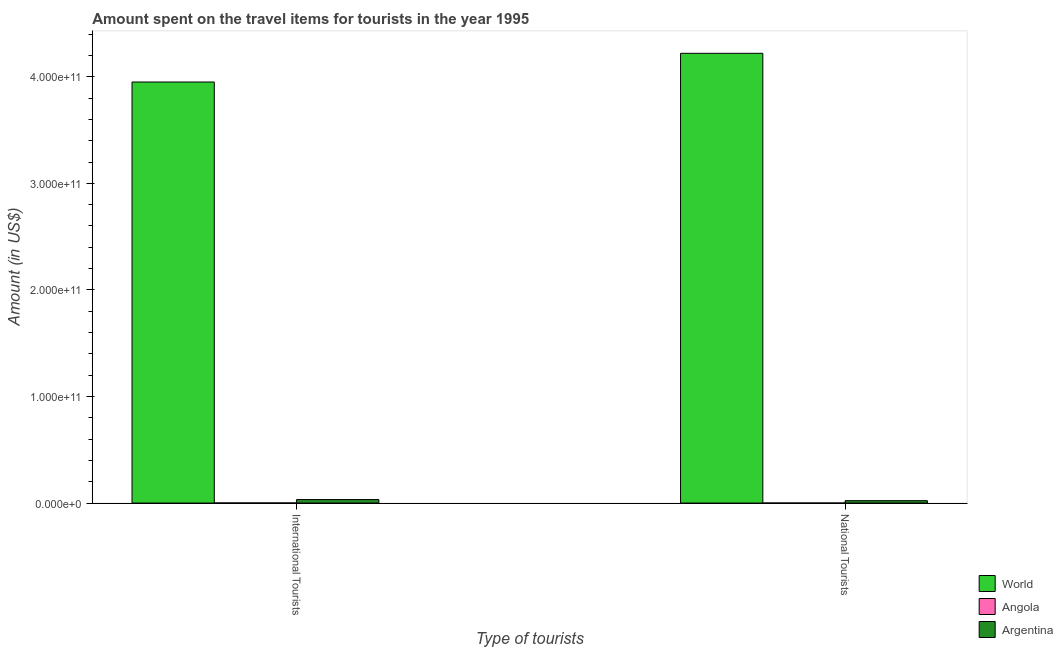How many different coloured bars are there?
Keep it short and to the point. 3. How many groups of bars are there?
Offer a very short reply. 2. What is the label of the 2nd group of bars from the left?
Your answer should be compact. National Tourists. What is the amount spent on travel items of national tourists in World?
Offer a terse response. 4.22e+11. Across all countries, what is the maximum amount spent on travel items of international tourists?
Keep it short and to the point. 3.95e+11. Across all countries, what is the minimum amount spent on travel items of international tourists?
Provide a short and direct response. 7.50e+07. In which country was the amount spent on travel items of international tourists minimum?
Offer a terse response. Angola. What is the total amount spent on travel items of national tourists in the graph?
Your response must be concise. 4.24e+11. What is the difference between the amount spent on travel items of international tourists in Argentina and that in World?
Offer a terse response. -3.92e+11. What is the difference between the amount spent on travel items of national tourists in World and the amount spent on travel items of international tourists in Argentina?
Your answer should be very brief. 4.19e+11. What is the average amount spent on travel items of national tourists per country?
Your answer should be very brief. 1.41e+11. What is the difference between the amount spent on travel items of national tourists and amount spent on travel items of international tourists in Angola?
Offer a very short reply. -6.50e+07. In how many countries, is the amount spent on travel items of national tourists greater than 100000000000 US$?
Give a very brief answer. 1. What is the ratio of the amount spent on travel items of national tourists in Argentina to that in World?
Provide a succinct answer. 0.01. Is the amount spent on travel items of international tourists in Angola less than that in Argentina?
Give a very brief answer. Yes. What does the 3rd bar from the left in National Tourists represents?
Offer a terse response. Argentina. What does the 3rd bar from the right in National Tourists represents?
Offer a very short reply. World. Are all the bars in the graph horizontal?
Your answer should be compact. No. What is the difference between two consecutive major ticks on the Y-axis?
Keep it short and to the point. 1.00e+11. Does the graph contain any zero values?
Give a very brief answer. No. Does the graph contain grids?
Keep it short and to the point. No. What is the title of the graph?
Provide a succinct answer. Amount spent on the travel items for tourists in the year 1995. Does "Sierra Leone" appear as one of the legend labels in the graph?
Give a very brief answer. No. What is the label or title of the X-axis?
Give a very brief answer. Type of tourists. What is the Amount (in US$) of World in International Tourists?
Give a very brief answer. 3.95e+11. What is the Amount (in US$) of Angola in International Tourists?
Offer a terse response. 7.50e+07. What is the Amount (in US$) in Argentina in International Tourists?
Ensure brevity in your answer.  3.28e+09. What is the Amount (in US$) of World in National Tourists?
Make the answer very short. 4.22e+11. What is the Amount (in US$) of Argentina in National Tourists?
Offer a very short reply. 2.22e+09. Across all Type of tourists, what is the maximum Amount (in US$) of World?
Provide a short and direct response. 4.22e+11. Across all Type of tourists, what is the maximum Amount (in US$) of Angola?
Your response must be concise. 7.50e+07. Across all Type of tourists, what is the maximum Amount (in US$) of Argentina?
Your response must be concise. 3.28e+09. Across all Type of tourists, what is the minimum Amount (in US$) in World?
Provide a succinct answer. 3.95e+11. Across all Type of tourists, what is the minimum Amount (in US$) of Argentina?
Provide a succinct answer. 2.22e+09. What is the total Amount (in US$) of World in the graph?
Keep it short and to the point. 8.17e+11. What is the total Amount (in US$) of Angola in the graph?
Your response must be concise. 8.50e+07. What is the total Amount (in US$) of Argentina in the graph?
Make the answer very short. 5.50e+09. What is the difference between the Amount (in US$) of World in International Tourists and that in National Tourists?
Offer a terse response. -2.69e+1. What is the difference between the Amount (in US$) in Angola in International Tourists and that in National Tourists?
Your answer should be compact. 6.50e+07. What is the difference between the Amount (in US$) of Argentina in International Tourists and that in National Tourists?
Ensure brevity in your answer.  1.06e+09. What is the difference between the Amount (in US$) in World in International Tourists and the Amount (in US$) in Angola in National Tourists?
Your answer should be very brief. 3.95e+11. What is the difference between the Amount (in US$) of World in International Tourists and the Amount (in US$) of Argentina in National Tourists?
Provide a short and direct response. 3.93e+11. What is the difference between the Amount (in US$) of Angola in International Tourists and the Amount (in US$) of Argentina in National Tourists?
Ensure brevity in your answer.  -2.15e+09. What is the average Amount (in US$) of World per Type of tourists?
Your answer should be very brief. 4.09e+11. What is the average Amount (in US$) of Angola per Type of tourists?
Offer a very short reply. 4.25e+07. What is the average Amount (in US$) in Argentina per Type of tourists?
Offer a terse response. 2.75e+09. What is the difference between the Amount (in US$) in World and Amount (in US$) in Angola in International Tourists?
Make the answer very short. 3.95e+11. What is the difference between the Amount (in US$) in World and Amount (in US$) in Argentina in International Tourists?
Make the answer very short. 3.92e+11. What is the difference between the Amount (in US$) of Angola and Amount (in US$) of Argentina in International Tourists?
Keep it short and to the point. -3.20e+09. What is the difference between the Amount (in US$) of World and Amount (in US$) of Angola in National Tourists?
Offer a terse response. 4.22e+11. What is the difference between the Amount (in US$) in World and Amount (in US$) in Argentina in National Tourists?
Provide a short and direct response. 4.20e+11. What is the difference between the Amount (in US$) of Angola and Amount (in US$) of Argentina in National Tourists?
Keep it short and to the point. -2.21e+09. What is the ratio of the Amount (in US$) in World in International Tourists to that in National Tourists?
Ensure brevity in your answer.  0.94. What is the ratio of the Amount (in US$) in Argentina in International Tourists to that in National Tourists?
Your answer should be very brief. 1.48. What is the difference between the highest and the second highest Amount (in US$) of World?
Offer a terse response. 2.69e+1. What is the difference between the highest and the second highest Amount (in US$) in Angola?
Your response must be concise. 6.50e+07. What is the difference between the highest and the second highest Amount (in US$) of Argentina?
Keep it short and to the point. 1.06e+09. What is the difference between the highest and the lowest Amount (in US$) in World?
Provide a short and direct response. 2.69e+1. What is the difference between the highest and the lowest Amount (in US$) of Angola?
Provide a short and direct response. 6.50e+07. What is the difference between the highest and the lowest Amount (in US$) of Argentina?
Your answer should be very brief. 1.06e+09. 